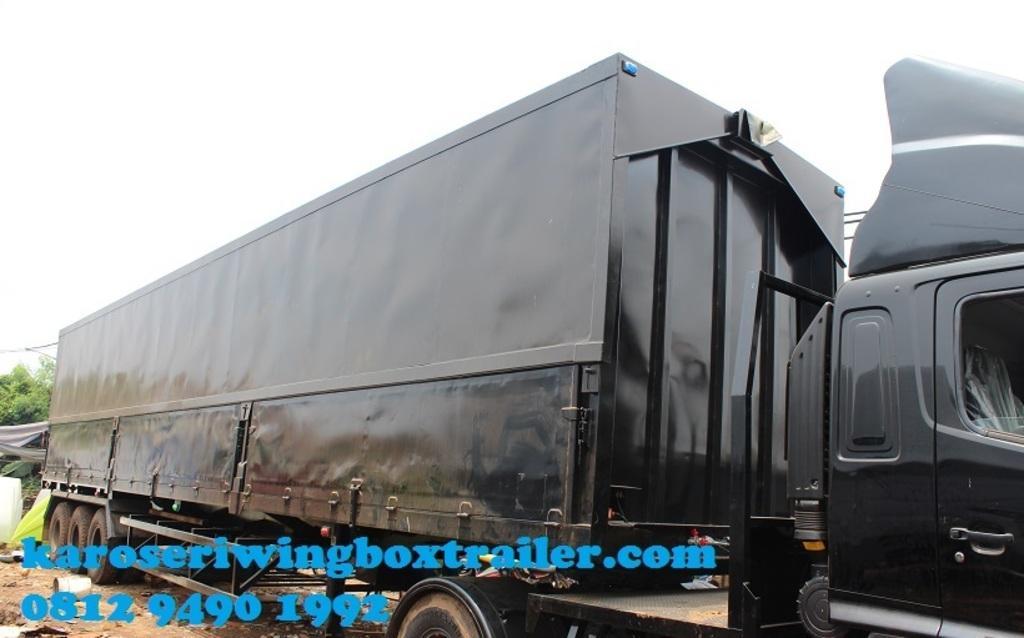Describe this image in one or two sentences. There is a truck container. On the left side there are trees. In the background there is sky. And something is written on the image. 